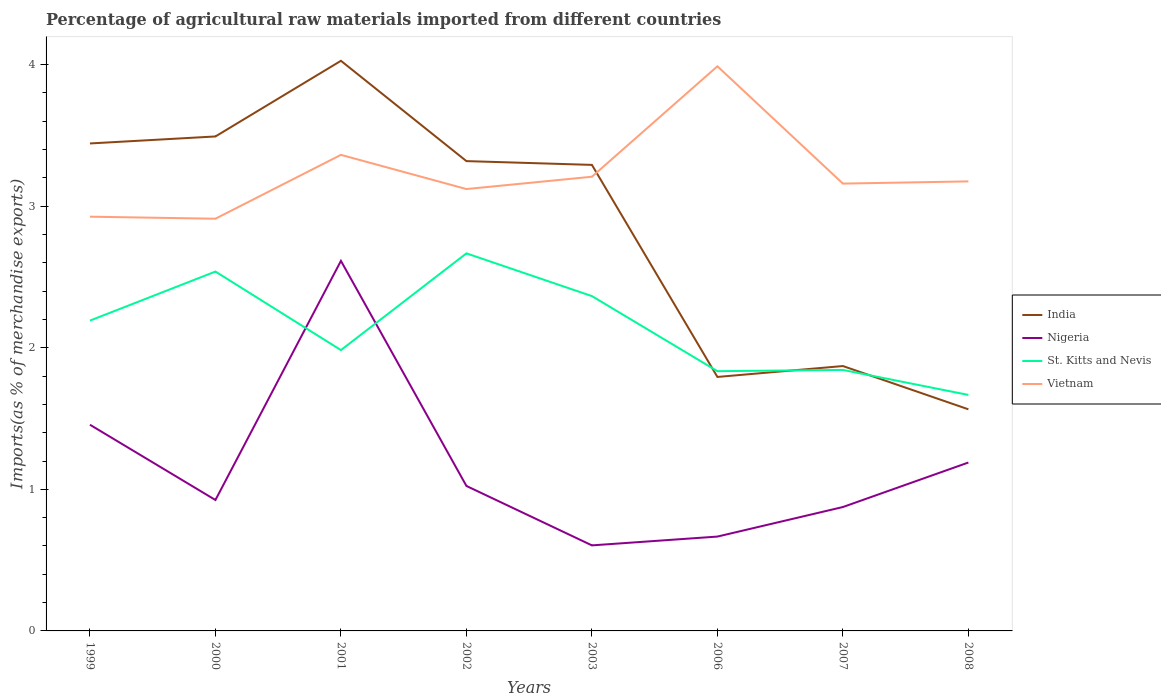How many different coloured lines are there?
Give a very brief answer. 4. Across all years, what is the maximum percentage of imports to different countries in Vietnam?
Offer a very short reply. 2.91. What is the total percentage of imports to different countries in St. Kitts and Nevis in the graph?
Give a very brief answer. -0.35. What is the difference between the highest and the second highest percentage of imports to different countries in Vietnam?
Your response must be concise. 1.08. What is the difference between the highest and the lowest percentage of imports to different countries in Nigeria?
Your response must be concise. 3. Is the percentage of imports to different countries in Vietnam strictly greater than the percentage of imports to different countries in Nigeria over the years?
Your answer should be very brief. No. How many years are there in the graph?
Offer a very short reply. 8. What is the difference between two consecutive major ticks on the Y-axis?
Ensure brevity in your answer.  1. Are the values on the major ticks of Y-axis written in scientific E-notation?
Provide a succinct answer. No. Does the graph contain any zero values?
Ensure brevity in your answer.  No. Does the graph contain grids?
Provide a short and direct response. No. How are the legend labels stacked?
Provide a short and direct response. Vertical. What is the title of the graph?
Offer a very short reply. Percentage of agricultural raw materials imported from different countries. Does "Burkina Faso" appear as one of the legend labels in the graph?
Offer a terse response. No. What is the label or title of the Y-axis?
Your answer should be very brief. Imports(as % of merchandise exports). What is the Imports(as % of merchandise exports) in India in 1999?
Ensure brevity in your answer.  3.44. What is the Imports(as % of merchandise exports) of Nigeria in 1999?
Provide a succinct answer. 1.46. What is the Imports(as % of merchandise exports) of St. Kitts and Nevis in 1999?
Ensure brevity in your answer.  2.19. What is the Imports(as % of merchandise exports) of Vietnam in 1999?
Keep it short and to the point. 2.93. What is the Imports(as % of merchandise exports) of India in 2000?
Your answer should be very brief. 3.49. What is the Imports(as % of merchandise exports) of Nigeria in 2000?
Provide a short and direct response. 0.92. What is the Imports(as % of merchandise exports) of St. Kitts and Nevis in 2000?
Ensure brevity in your answer.  2.54. What is the Imports(as % of merchandise exports) in Vietnam in 2000?
Provide a short and direct response. 2.91. What is the Imports(as % of merchandise exports) of India in 2001?
Your answer should be very brief. 4.03. What is the Imports(as % of merchandise exports) in Nigeria in 2001?
Provide a short and direct response. 2.61. What is the Imports(as % of merchandise exports) of St. Kitts and Nevis in 2001?
Offer a terse response. 1.98. What is the Imports(as % of merchandise exports) of Vietnam in 2001?
Give a very brief answer. 3.36. What is the Imports(as % of merchandise exports) in India in 2002?
Make the answer very short. 3.32. What is the Imports(as % of merchandise exports) in Nigeria in 2002?
Your answer should be compact. 1.02. What is the Imports(as % of merchandise exports) of St. Kitts and Nevis in 2002?
Give a very brief answer. 2.67. What is the Imports(as % of merchandise exports) in Vietnam in 2002?
Keep it short and to the point. 3.12. What is the Imports(as % of merchandise exports) of India in 2003?
Your answer should be very brief. 3.29. What is the Imports(as % of merchandise exports) of Nigeria in 2003?
Keep it short and to the point. 0.6. What is the Imports(as % of merchandise exports) in St. Kitts and Nevis in 2003?
Make the answer very short. 2.36. What is the Imports(as % of merchandise exports) in Vietnam in 2003?
Make the answer very short. 3.21. What is the Imports(as % of merchandise exports) of India in 2006?
Your response must be concise. 1.79. What is the Imports(as % of merchandise exports) in Nigeria in 2006?
Your response must be concise. 0.67. What is the Imports(as % of merchandise exports) in St. Kitts and Nevis in 2006?
Your answer should be compact. 1.83. What is the Imports(as % of merchandise exports) of Vietnam in 2006?
Give a very brief answer. 3.99. What is the Imports(as % of merchandise exports) of India in 2007?
Your answer should be compact. 1.87. What is the Imports(as % of merchandise exports) of Nigeria in 2007?
Keep it short and to the point. 0.87. What is the Imports(as % of merchandise exports) of St. Kitts and Nevis in 2007?
Provide a short and direct response. 1.84. What is the Imports(as % of merchandise exports) of Vietnam in 2007?
Ensure brevity in your answer.  3.16. What is the Imports(as % of merchandise exports) in India in 2008?
Offer a very short reply. 1.57. What is the Imports(as % of merchandise exports) of Nigeria in 2008?
Keep it short and to the point. 1.19. What is the Imports(as % of merchandise exports) of St. Kitts and Nevis in 2008?
Your answer should be very brief. 1.67. What is the Imports(as % of merchandise exports) in Vietnam in 2008?
Your answer should be compact. 3.17. Across all years, what is the maximum Imports(as % of merchandise exports) in India?
Give a very brief answer. 4.03. Across all years, what is the maximum Imports(as % of merchandise exports) in Nigeria?
Give a very brief answer. 2.61. Across all years, what is the maximum Imports(as % of merchandise exports) in St. Kitts and Nevis?
Make the answer very short. 2.67. Across all years, what is the maximum Imports(as % of merchandise exports) in Vietnam?
Offer a very short reply. 3.99. Across all years, what is the minimum Imports(as % of merchandise exports) in India?
Provide a short and direct response. 1.57. Across all years, what is the minimum Imports(as % of merchandise exports) in Nigeria?
Give a very brief answer. 0.6. Across all years, what is the minimum Imports(as % of merchandise exports) in St. Kitts and Nevis?
Provide a short and direct response. 1.67. Across all years, what is the minimum Imports(as % of merchandise exports) of Vietnam?
Make the answer very short. 2.91. What is the total Imports(as % of merchandise exports) in India in the graph?
Keep it short and to the point. 22.8. What is the total Imports(as % of merchandise exports) in Nigeria in the graph?
Your response must be concise. 9.35. What is the total Imports(as % of merchandise exports) in St. Kitts and Nevis in the graph?
Offer a very short reply. 17.09. What is the total Imports(as % of merchandise exports) in Vietnam in the graph?
Provide a succinct answer. 25.85. What is the difference between the Imports(as % of merchandise exports) of India in 1999 and that in 2000?
Your response must be concise. -0.05. What is the difference between the Imports(as % of merchandise exports) of Nigeria in 1999 and that in 2000?
Your answer should be compact. 0.53. What is the difference between the Imports(as % of merchandise exports) in St. Kitts and Nevis in 1999 and that in 2000?
Your answer should be very brief. -0.35. What is the difference between the Imports(as % of merchandise exports) in Vietnam in 1999 and that in 2000?
Provide a succinct answer. 0.01. What is the difference between the Imports(as % of merchandise exports) in India in 1999 and that in 2001?
Offer a very short reply. -0.58. What is the difference between the Imports(as % of merchandise exports) in Nigeria in 1999 and that in 2001?
Give a very brief answer. -1.16. What is the difference between the Imports(as % of merchandise exports) in St. Kitts and Nevis in 1999 and that in 2001?
Your response must be concise. 0.21. What is the difference between the Imports(as % of merchandise exports) in Vietnam in 1999 and that in 2001?
Your answer should be compact. -0.44. What is the difference between the Imports(as % of merchandise exports) of India in 1999 and that in 2002?
Keep it short and to the point. 0.12. What is the difference between the Imports(as % of merchandise exports) of Nigeria in 1999 and that in 2002?
Keep it short and to the point. 0.43. What is the difference between the Imports(as % of merchandise exports) in St. Kitts and Nevis in 1999 and that in 2002?
Provide a succinct answer. -0.47. What is the difference between the Imports(as % of merchandise exports) in Vietnam in 1999 and that in 2002?
Your answer should be compact. -0.2. What is the difference between the Imports(as % of merchandise exports) of India in 1999 and that in 2003?
Provide a short and direct response. 0.15. What is the difference between the Imports(as % of merchandise exports) of Nigeria in 1999 and that in 2003?
Give a very brief answer. 0.85. What is the difference between the Imports(as % of merchandise exports) in St. Kitts and Nevis in 1999 and that in 2003?
Your answer should be very brief. -0.17. What is the difference between the Imports(as % of merchandise exports) of Vietnam in 1999 and that in 2003?
Make the answer very short. -0.28. What is the difference between the Imports(as % of merchandise exports) in India in 1999 and that in 2006?
Your response must be concise. 1.65. What is the difference between the Imports(as % of merchandise exports) of Nigeria in 1999 and that in 2006?
Provide a short and direct response. 0.79. What is the difference between the Imports(as % of merchandise exports) of St. Kitts and Nevis in 1999 and that in 2006?
Keep it short and to the point. 0.36. What is the difference between the Imports(as % of merchandise exports) of Vietnam in 1999 and that in 2006?
Keep it short and to the point. -1.06. What is the difference between the Imports(as % of merchandise exports) in India in 1999 and that in 2007?
Your response must be concise. 1.57. What is the difference between the Imports(as % of merchandise exports) of Nigeria in 1999 and that in 2007?
Your answer should be very brief. 0.58. What is the difference between the Imports(as % of merchandise exports) in St. Kitts and Nevis in 1999 and that in 2007?
Ensure brevity in your answer.  0.35. What is the difference between the Imports(as % of merchandise exports) of Vietnam in 1999 and that in 2007?
Provide a succinct answer. -0.23. What is the difference between the Imports(as % of merchandise exports) in India in 1999 and that in 2008?
Provide a succinct answer. 1.88. What is the difference between the Imports(as % of merchandise exports) of Nigeria in 1999 and that in 2008?
Your answer should be compact. 0.27. What is the difference between the Imports(as % of merchandise exports) in St. Kitts and Nevis in 1999 and that in 2008?
Provide a short and direct response. 0.52. What is the difference between the Imports(as % of merchandise exports) of Vietnam in 1999 and that in 2008?
Your answer should be very brief. -0.25. What is the difference between the Imports(as % of merchandise exports) of India in 2000 and that in 2001?
Provide a succinct answer. -0.53. What is the difference between the Imports(as % of merchandise exports) in Nigeria in 2000 and that in 2001?
Provide a short and direct response. -1.69. What is the difference between the Imports(as % of merchandise exports) of St. Kitts and Nevis in 2000 and that in 2001?
Give a very brief answer. 0.55. What is the difference between the Imports(as % of merchandise exports) in Vietnam in 2000 and that in 2001?
Provide a short and direct response. -0.45. What is the difference between the Imports(as % of merchandise exports) in India in 2000 and that in 2002?
Provide a succinct answer. 0.17. What is the difference between the Imports(as % of merchandise exports) of Nigeria in 2000 and that in 2002?
Your response must be concise. -0.1. What is the difference between the Imports(as % of merchandise exports) in St. Kitts and Nevis in 2000 and that in 2002?
Your answer should be compact. -0.13. What is the difference between the Imports(as % of merchandise exports) of Vietnam in 2000 and that in 2002?
Offer a terse response. -0.21. What is the difference between the Imports(as % of merchandise exports) of India in 2000 and that in 2003?
Offer a terse response. 0.2. What is the difference between the Imports(as % of merchandise exports) in Nigeria in 2000 and that in 2003?
Offer a very short reply. 0.32. What is the difference between the Imports(as % of merchandise exports) in St. Kitts and Nevis in 2000 and that in 2003?
Offer a terse response. 0.17. What is the difference between the Imports(as % of merchandise exports) of Vietnam in 2000 and that in 2003?
Offer a very short reply. -0.3. What is the difference between the Imports(as % of merchandise exports) in India in 2000 and that in 2006?
Make the answer very short. 1.7. What is the difference between the Imports(as % of merchandise exports) of Nigeria in 2000 and that in 2006?
Provide a succinct answer. 0.26. What is the difference between the Imports(as % of merchandise exports) of St. Kitts and Nevis in 2000 and that in 2006?
Offer a very short reply. 0.7. What is the difference between the Imports(as % of merchandise exports) in Vietnam in 2000 and that in 2006?
Keep it short and to the point. -1.08. What is the difference between the Imports(as % of merchandise exports) in India in 2000 and that in 2007?
Your answer should be very brief. 1.62. What is the difference between the Imports(as % of merchandise exports) in Nigeria in 2000 and that in 2007?
Provide a succinct answer. 0.05. What is the difference between the Imports(as % of merchandise exports) in St. Kitts and Nevis in 2000 and that in 2007?
Provide a succinct answer. 0.69. What is the difference between the Imports(as % of merchandise exports) of Vietnam in 2000 and that in 2007?
Provide a succinct answer. -0.25. What is the difference between the Imports(as % of merchandise exports) in India in 2000 and that in 2008?
Keep it short and to the point. 1.93. What is the difference between the Imports(as % of merchandise exports) of Nigeria in 2000 and that in 2008?
Offer a terse response. -0.26. What is the difference between the Imports(as % of merchandise exports) of St. Kitts and Nevis in 2000 and that in 2008?
Your response must be concise. 0.87. What is the difference between the Imports(as % of merchandise exports) of Vietnam in 2000 and that in 2008?
Keep it short and to the point. -0.26. What is the difference between the Imports(as % of merchandise exports) in India in 2001 and that in 2002?
Give a very brief answer. 0.71. What is the difference between the Imports(as % of merchandise exports) of Nigeria in 2001 and that in 2002?
Give a very brief answer. 1.59. What is the difference between the Imports(as % of merchandise exports) in St. Kitts and Nevis in 2001 and that in 2002?
Keep it short and to the point. -0.68. What is the difference between the Imports(as % of merchandise exports) of Vietnam in 2001 and that in 2002?
Your response must be concise. 0.24. What is the difference between the Imports(as % of merchandise exports) of India in 2001 and that in 2003?
Your response must be concise. 0.73. What is the difference between the Imports(as % of merchandise exports) in Nigeria in 2001 and that in 2003?
Ensure brevity in your answer.  2.01. What is the difference between the Imports(as % of merchandise exports) of St. Kitts and Nevis in 2001 and that in 2003?
Keep it short and to the point. -0.38. What is the difference between the Imports(as % of merchandise exports) in Vietnam in 2001 and that in 2003?
Your answer should be compact. 0.15. What is the difference between the Imports(as % of merchandise exports) in India in 2001 and that in 2006?
Give a very brief answer. 2.23. What is the difference between the Imports(as % of merchandise exports) of Nigeria in 2001 and that in 2006?
Provide a short and direct response. 1.95. What is the difference between the Imports(as % of merchandise exports) of St. Kitts and Nevis in 2001 and that in 2006?
Offer a very short reply. 0.15. What is the difference between the Imports(as % of merchandise exports) in Vietnam in 2001 and that in 2006?
Your answer should be compact. -0.63. What is the difference between the Imports(as % of merchandise exports) in India in 2001 and that in 2007?
Your answer should be very brief. 2.16. What is the difference between the Imports(as % of merchandise exports) of Nigeria in 2001 and that in 2007?
Give a very brief answer. 1.74. What is the difference between the Imports(as % of merchandise exports) of St. Kitts and Nevis in 2001 and that in 2007?
Keep it short and to the point. 0.14. What is the difference between the Imports(as % of merchandise exports) of Vietnam in 2001 and that in 2007?
Make the answer very short. 0.2. What is the difference between the Imports(as % of merchandise exports) of India in 2001 and that in 2008?
Offer a very short reply. 2.46. What is the difference between the Imports(as % of merchandise exports) in Nigeria in 2001 and that in 2008?
Make the answer very short. 1.42. What is the difference between the Imports(as % of merchandise exports) in St. Kitts and Nevis in 2001 and that in 2008?
Make the answer very short. 0.32. What is the difference between the Imports(as % of merchandise exports) in Vietnam in 2001 and that in 2008?
Make the answer very short. 0.19. What is the difference between the Imports(as % of merchandise exports) in India in 2002 and that in 2003?
Keep it short and to the point. 0.03. What is the difference between the Imports(as % of merchandise exports) in Nigeria in 2002 and that in 2003?
Give a very brief answer. 0.42. What is the difference between the Imports(as % of merchandise exports) of St. Kitts and Nevis in 2002 and that in 2003?
Make the answer very short. 0.3. What is the difference between the Imports(as % of merchandise exports) in Vietnam in 2002 and that in 2003?
Give a very brief answer. -0.09. What is the difference between the Imports(as % of merchandise exports) in India in 2002 and that in 2006?
Give a very brief answer. 1.52. What is the difference between the Imports(as % of merchandise exports) in Nigeria in 2002 and that in 2006?
Keep it short and to the point. 0.36. What is the difference between the Imports(as % of merchandise exports) in St. Kitts and Nevis in 2002 and that in 2006?
Offer a terse response. 0.83. What is the difference between the Imports(as % of merchandise exports) in Vietnam in 2002 and that in 2006?
Keep it short and to the point. -0.87. What is the difference between the Imports(as % of merchandise exports) in India in 2002 and that in 2007?
Your response must be concise. 1.45. What is the difference between the Imports(as % of merchandise exports) in Nigeria in 2002 and that in 2007?
Your answer should be very brief. 0.15. What is the difference between the Imports(as % of merchandise exports) in St. Kitts and Nevis in 2002 and that in 2007?
Provide a short and direct response. 0.82. What is the difference between the Imports(as % of merchandise exports) in Vietnam in 2002 and that in 2007?
Your answer should be compact. -0.04. What is the difference between the Imports(as % of merchandise exports) of India in 2002 and that in 2008?
Keep it short and to the point. 1.75. What is the difference between the Imports(as % of merchandise exports) in Nigeria in 2002 and that in 2008?
Make the answer very short. -0.17. What is the difference between the Imports(as % of merchandise exports) of Vietnam in 2002 and that in 2008?
Give a very brief answer. -0.05. What is the difference between the Imports(as % of merchandise exports) in India in 2003 and that in 2006?
Provide a short and direct response. 1.5. What is the difference between the Imports(as % of merchandise exports) in Nigeria in 2003 and that in 2006?
Offer a very short reply. -0.06. What is the difference between the Imports(as % of merchandise exports) in St. Kitts and Nevis in 2003 and that in 2006?
Your answer should be very brief. 0.53. What is the difference between the Imports(as % of merchandise exports) in Vietnam in 2003 and that in 2006?
Offer a terse response. -0.78. What is the difference between the Imports(as % of merchandise exports) of India in 2003 and that in 2007?
Offer a terse response. 1.42. What is the difference between the Imports(as % of merchandise exports) in Nigeria in 2003 and that in 2007?
Give a very brief answer. -0.27. What is the difference between the Imports(as % of merchandise exports) in St. Kitts and Nevis in 2003 and that in 2007?
Provide a short and direct response. 0.52. What is the difference between the Imports(as % of merchandise exports) of Vietnam in 2003 and that in 2007?
Ensure brevity in your answer.  0.05. What is the difference between the Imports(as % of merchandise exports) in India in 2003 and that in 2008?
Provide a short and direct response. 1.73. What is the difference between the Imports(as % of merchandise exports) in Nigeria in 2003 and that in 2008?
Provide a short and direct response. -0.59. What is the difference between the Imports(as % of merchandise exports) of St. Kitts and Nevis in 2003 and that in 2008?
Keep it short and to the point. 0.7. What is the difference between the Imports(as % of merchandise exports) in Vietnam in 2003 and that in 2008?
Make the answer very short. 0.03. What is the difference between the Imports(as % of merchandise exports) in India in 2006 and that in 2007?
Provide a short and direct response. -0.08. What is the difference between the Imports(as % of merchandise exports) of Nigeria in 2006 and that in 2007?
Make the answer very short. -0.21. What is the difference between the Imports(as % of merchandise exports) of St. Kitts and Nevis in 2006 and that in 2007?
Offer a terse response. -0.01. What is the difference between the Imports(as % of merchandise exports) in Vietnam in 2006 and that in 2007?
Offer a terse response. 0.83. What is the difference between the Imports(as % of merchandise exports) in India in 2006 and that in 2008?
Make the answer very short. 0.23. What is the difference between the Imports(as % of merchandise exports) in Nigeria in 2006 and that in 2008?
Your answer should be compact. -0.52. What is the difference between the Imports(as % of merchandise exports) in St. Kitts and Nevis in 2006 and that in 2008?
Your response must be concise. 0.17. What is the difference between the Imports(as % of merchandise exports) in Vietnam in 2006 and that in 2008?
Make the answer very short. 0.81. What is the difference between the Imports(as % of merchandise exports) in India in 2007 and that in 2008?
Provide a succinct answer. 0.31. What is the difference between the Imports(as % of merchandise exports) of Nigeria in 2007 and that in 2008?
Give a very brief answer. -0.31. What is the difference between the Imports(as % of merchandise exports) in St. Kitts and Nevis in 2007 and that in 2008?
Your response must be concise. 0.18. What is the difference between the Imports(as % of merchandise exports) of Vietnam in 2007 and that in 2008?
Make the answer very short. -0.02. What is the difference between the Imports(as % of merchandise exports) of India in 1999 and the Imports(as % of merchandise exports) of Nigeria in 2000?
Offer a very short reply. 2.52. What is the difference between the Imports(as % of merchandise exports) of India in 1999 and the Imports(as % of merchandise exports) of St. Kitts and Nevis in 2000?
Your answer should be compact. 0.9. What is the difference between the Imports(as % of merchandise exports) of India in 1999 and the Imports(as % of merchandise exports) of Vietnam in 2000?
Your response must be concise. 0.53. What is the difference between the Imports(as % of merchandise exports) of Nigeria in 1999 and the Imports(as % of merchandise exports) of St. Kitts and Nevis in 2000?
Ensure brevity in your answer.  -1.08. What is the difference between the Imports(as % of merchandise exports) in Nigeria in 1999 and the Imports(as % of merchandise exports) in Vietnam in 2000?
Give a very brief answer. -1.45. What is the difference between the Imports(as % of merchandise exports) of St. Kitts and Nevis in 1999 and the Imports(as % of merchandise exports) of Vietnam in 2000?
Provide a short and direct response. -0.72. What is the difference between the Imports(as % of merchandise exports) of India in 1999 and the Imports(as % of merchandise exports) of Nigeria in 2001?
Offer a terse response. 0.83. What is the difference between the Imports(as % of merchandise exports) in India in 1999 and the Imports(as % of merchandise exports) in St. Kitts and Nevis in 2001?
Your answer should be very brief. 1.46. What is the difference between the Imports(as % of merchandise exports) in India in 1999 and the Imports(as % of merchandise exports) in Vietnam in 2001?
Ensure brevity in your answer.  0.08. What is the difference between the Imports(as % of merchandise exports) in Nigeria in 1999 and the Imports(as % of merchandise exports) in St. Kitts and Nevis in 2001?
Keep it short and to the point. -0.53. What is the difference between the Imports(as % of merchandise exports) in Nigeria in 1999 and the Imports(as % of merchandise exports) in Vietnam in 2001?
Your response must be concise. -1.91. What is the difference between the Imports(as % of merchandise exports) in St. Kitts and Nevis in 1999 and the Imports(as % of merchandise exports) in Vietnam in 2001?
Offer a terse response. -1.17. What is the difference between the Imports(as % of merchandise exports) of India in 1999 and the Imports(as % of merchandise exports) of Nigeria in 2002?
Offer a very short reply. 2.42. What is the difference between the Imports(as % of merchandise exports) in India in 1999 and the Imports(as % of merchandise exports) in St. Kitts and Nevis in 2002?
Keep it short and to the point. 0.78. What is the difference between the Imports(as % of merchandise exports) in India in 1999 and the Imports(as % of merchandise exports) in Vietnam in 2002?
Your response must be concise. 0.32. What is the difference between the Imports(as % of merchandise exports) in Nigeria in 1999 and the Imports(as % of merchandise exports) in St. Kitts and Nevis in 2002?
Your answer should be compact. -1.21. What is the difference between the Imports(as % of merchandise exports) in Nigeria in 1999 and the Imports(as % of merchandise exports) in Vietnam in 2002?
Keep it short and to the point. -1.66. What is the difference between the Imports(as % of merchandise exports) in St. Kitts and Nevis in 1999 and the Imports(as % of merchandise exports) in Vietnam in 2002?
Your response must be concise. -0.93. What is the difference between the Imports(as % of merchandise exports) in India in 1999 and the Imports(as % of merchandise exports) in Nigeria in 2003?
Give a very brief answer. 2.84. What is the difference between the Imports(as % of merchandise exports) of India in 1999 and the Imports(as % of merchandise exports) of St. Kitts and Nevis in 2003?
Your answer should be very brief. 1.08. What is the difference between the Imports(as % of merchandise exports) in India in 1999 and the Imports(as % of merchandise exports) in Vietnam in 2003?
Keep it short and to the point. 0.24. What is the difference between the Imports(as % of merchandise exports) in Nigeria in 1999 and the Imports(as % of merchandise exports) in St. Kitts and Nevis in 2003?
Give a very brief answer. -0.91. What is the difference between the Imports(as % of merchandise exports) of Nigeria in 1999 and the Imports(as % of merchandise exports) of Vietnam in 2003?
Offer a terse response. -1.75. What is the difference between the Imports(as % of merchandise exports) in St. Kitts and Nevis in 1999 and the Imports(as % of merchandise exports) in Vietnam in 2003?
Offer a terse response. -1.02. What is the difference between the Imports(as % of merchandise exports) in India in 1999 and the Imports(as % of merchandise exports) in Nigeria in 2006?
Your answer should be very brief. 2.78. What is the difference between the Imports(as % of merchandise exports) of India in 1999 and the Imports(as % of merchandise exports) of St. Kitts and Nevis in 2006?
Give a very brief answer. 1.61. What is the difference between the Imports(as % of merchandise exports) of India in 1999 and the Imports(as % of merchandise exports) of Vietnam in 2006?
Your response must be concise. -0.55. What is the difference between the Imports(as % of merchandise exports) in Nigeria in 1999 and the Imports(as % of merchandise exports) in St. Kitts and Nevis in 2006?
Provide a short and direct response. -0.38. What is the difference between the Imports(as % of merchandise exports) in Nigeria in 1999 and the Imports(as % of merchandise exports) in Vietnam in 2006?
Provide a short and direct response. -2.53. What is the difference between the Imports(as % of merchandise exports) of St. Kitts and Nevis in 1999 and the Imports(as % of merchandise exports) of Vietnam in 2006?
Provide a succinct answer. -1.8. What is the difference between the Imports(as % of merchandise exports) in India in 1999 and the Imports(as % of merchandise exports) in Nigeria in 2007?
Offer a terse response. 2.57. What is the difference between the Imports(as % of merchandise exports) of India in 1999 and the Imports(as % of merchandise exports) of St. Kitts and Nevis in 2007?
Ensure brevity in your answer.  1.6. What is the difference between the Imports(as % of merchandise exports) in India in 1999 and the Imports(as % of merchandise exports) in Vietnam in 2007?
Keep it short and to the point. 0.28. What is the difference between the Imports(as % of merchandise exports) in Nigeria in 1999 and the Imports(as % of merchandise exports) in St. Kitts and Nevis in 2007?
Provide a succinct answer. -0.39. What is the difference between the Imports(as % of merchandise exports) of Nigeria in 1999 and the Imports(as % of merchandise exports) of Vietnam in 2007?
Keep it short and to the point. -1.7. What is the difference between the Imports(as % of merchandise exports) in St. Kitts and Nevis in 1999 and the Imports(as % of merchandise exports) in Vietnam in 2007?
Your response must be concise. -0.97. What is the difference between the Imports(as % of merchandise exports) in India in 1999 and the Imports(as % of merchandise exports) in Nigeria in 2008?
Make the answer very short. 2.25. What is the difference between the Imports(as % of merchandise exports) of India in 1999 and the Imports(as % of merchandise exports) of St. Kitts and Nevis in 2008?
Give a very brief answer. 1.78. What is the difference between the Imports(as % of merchandise exports) of India in 1999 and the Imports(as % of merchandise exports) of Vietnam in 2008?
Your answer should be compact. 0.27. What is the difference between the Imports(as % of merchandise exports) in Nigeria in 1999 and the Imports(as % of merchandise exports) in St. Kitts and Nevis in 2008?
Your response must be concise. -0.21. What is the difference between the Imports(as % of merchandise exports) of Nigeria in 1999 and the Imports(as % of merchandise exports) of Vietnam in 2008?
Ensure brevity in your answer.  -1.72. What is the difference between the Imports(as % of merchandise exports) in St. Kitts and Nevis in 1999 and the Imports(as % of merchandise exports) in Vietnam in 2008?
Offer a very short reply. -0.98. What is the difference between the Imports(as % of merchandise exports) of India in 2000 and the Imports(as % of merchandise exports) of Nigeria in 2001?
Offer a very short reply. 0.88. What is the difference between the Imports(as % of merchandise exports) of India in 2000 and the Imports(as % of merchandise exports) of St. Kitts and Nevis in 2001?
Give a very brief answer. 1.51. What is the difference between the Imports(as % of merchandise exports) of India in 2000 and the Imports(as % of merchandise exports) of Vietnam in 2001?
Give a very brief answer. 0.13. What is the difference between the Imports(as % of merchandise exports) of Nigeria in 2000 and the Imports(as % of merchandise exports) of St. Kitts and Nevis in 2001?
Offer a terse response. -1.06. What is the difference between the Imports(as % of merchandise exports) of Nigeria in 2000 and the Imports(as % of merchandise exports) of Vietnam in 2001?
Provide a short and direct response. -2.44. What is the difference between the Imports(as % of merchandise exports) of St. Kitts and Nevis in 2000 and the Imports(as % of merchandise exports) of Vietnam in 2001?
Give a very brief answer. -0.82. What is the difference between the Imports(as % of merchandise exports) in India in 2000 and the Imports(as % of merchandise exports) in Nigeria in 2002?
Your response must be concise. 2.47. What is the difference between the Imports(as % of merchandise exports) in India in 2000 and the Imports(as % of merchandise exports) in St. Kitts and Nevis in 2002?
Make the answer very short. 0.83. What is the difference between the Imports(as % of merchandise exports) of India in 2000 and the Imports(as % of merchandise exports) of Vietnam in 2002?
Your answer should be very brief. 0.37. What is the difference between the Imports(as % of merchandise exports) of Nigeria in 2000 and the Imports(as % of merchandise exports) of St. Kitts and Nevis in 2002?
Your answer should be compact. -1.74. What is the difference between the Imports(as % of merchandise exports) in Nigeria in 2000 and the Imports(as % of merchandise exports) in Vietnam in 2002?
Make the answer very short. -2.2. What is the difference between the Imports(as % of merchandise exports) in St. Kitts and Nevis in 2000 and the Imports(as % of merchandise exports) in Vietnam in 2002?
Keep it short and to the point. -0.58. What is the difference between the Imports(as % of merchandise exports) of India in 2000 and the Imports(as % of merchandise exports) of Nigeria in 2003?
Your response must be concise. 2.89. What is the difference between the Imports(as % of merchandise exports) of India in 2000 and the Imports(as % of merchandise exports) of St. Kitts and Nevis in 2003?
Your answer should be compact. 1.13. What is the difference between the Imports(as % of merchandise exports) of India in 2000 and the Imports(as % of merchandise exports) of Vietnam in 2003?
Ensure brevity in your answer.  0.28. What is the difference between the Imports(as % of merchandise exports) in Nigeria in 2000 and the Imports(as % of merchandise exports) in St. Kitts and Nevis in 2003?
Provide a succinct answer. -1.44. What is the difference between the Imports(as % of merchandise exports) in Nigeria in 2000 and the Imports(as % of merchandise exports) in Vietnam in 2003?
Offer a terse response. -2.28. What is the difference between the Imports(as % of merchandise exports) in St. Kitts and Nevis in 2000 and the Imports(as % of merchandise exports) in Vietnam in 2003?
Make the answer very short. -0.67. What is the difference between the Imports(as % of merchandise exports) of India in 2000 and the Imports(as % of merchandise exports) of Nigeria in 2006?
Keep it short and to the point. 2.83. What is the difference between the Imports(as % of merchandise exports) of India in 2000 and the Imports(as % of merchandise exports) of St. Kitts and Nevis in 2006?
Ensure brevity in your answer.  1.66. What is the difference between the Imports(as % of merchandise exports) of India in 2000 and the Imports(as % of merchandise exports) of Vietnam in 2006?
Ensure brevity in your answer.  -0.5. What is the difference between the Imports(as % of merchandise exports) in Nigeria in 2000 and the Imports(as % of merchandise exports) in St. Kitts and Nevis in 2006?
Provide a succinct answer. -0.91. What is the difference between the Imports(as % of merchandise exports) in Nigeria in 2000 and the Imports(as % of merchandise exports) in Vietnam in 2006?
Your answer should be very brief. -3.06. What is the difference between the Imports(as % of merchandise exports) of St. Kitts and Nevis in 2000 and the Imports(as % of merchandise exports) of Vietnam in 2006?
Make the answer very short. -1.45. What is the difference between the Imports(as % of merchandise exports) in India in 2000 and the Imports(as % of merchandise exports) in Nigeria in 2007?
Keep it short and to the point. 2.62. What is the difference between the Imports(as % of merchandise exports) of India in 2000 and the Imports(as % of merchandise exports) of St. Kitts and Nevis in 2007?
Your answer should be compact. 1.65. What is the difference between the Imports(as % of merchandise exports) of India in 2000 and the Imports(as % of merchandise exports) of Vietnam in 2007?
Ensure brevity in your answer.  0.33. What is the difference between the Imports(as % of merchandise exports) in Nigeria in 2000 and the Imports(as % of merchandise exports) in St. Kitts and Nevis in 2007?
Provide a succinct answer. -0.92. What is the difference between the Imports(as % of merchandise exports) of Nigeria in 2000 and the Imports(as % of merchandise exports) of Vietnam in 2007?
Offer a very short reply. -2.23. What is the difference between the Imports(as % of merchandise exports) of St. Kitts and Nevis in 2000 and the Imports(as % of merchandise exports) of Vietnam in 2007?
Offer a terse response. -0.62. What is the difference between the Imports(as % of merchandise exports) in India in 2000 and the Imports(as % of merchandise exports) in Nigeria in 2008?
Keep it short and to the point. 2.3. What is the difference between the Imports(as % of merchandise exports) of India in 2000 and the Imports(as % of merchandise exports) of St. Kitts and Nevis in 2008?
Ensure brevity in your answer.  1.83. What is the difference between the Imports(as % of merchandise exports) of India in 2000 and the Imports(as % of merchandise exports) of Vietnam in 2008?
Provide a succinct answer. 0.32. What is the difference between the Imports(as % of merchandise exports) of Nigeria in 2000 and the Imports(as % of merchandise exports) of St. Kitts and Nevis in 2008?
Offer a very short reply. -0.74. What is the difference between the Imports(as % of merchandise exports) of Nigeria in 2000 and the Imports(as % of merchandise exports) of Vietnam in 2008?
Your response must be concise. -2.25. What is the difference between the Imports(as % of merchandise exports) in St. Kitts and Nevis in 2000 and the Imports(as % of merchandise exports) in Vietnam in 2008?
Give a very brief answer. -0.64. What is the difference between the Imports(as % of merchandise exports) in India in 2001 and the Imports(as % of merchandise exports) in Nigeria in 2002?
Your answer should be compact. 3. What is the difference between the Imports(as % of merchandise exports) of India in 2001 and the Imports(as % of merchandise exports) of St. Kitts and Nevis in 2002?
Ensure brevity in your answer.  1.36. What is the difference between the Imports(as % of merchandise exports) in India in 2001 and the Imports(as % of merchandise exports) in Vietnam in 2002?
Ensure brevity in your answer.  0.91. What is the difference between the Imports(as % of merchandise exports) in Nigeria in 2001 and the Imports(as % of merchandise exports) in St. Kitts and Nevis in 2002?
Ensure brevity in your answer.  -0.05. What is the difference between the Imports(as % of merchandise exports) of Nigeria in 2001 and the Imports(as % of merchandise exports) of Vietnam in 2002?
Ensure brevity in your answer.  -0.51. What is the difference between the Imports(as % of merchandise exports) in St. Kitts and Nevis in 2001 and the Imports(as % of merchandise exports) in Vietnam in 2002?
Your answer should be very brief. -1.14. What is the difference between the Imports(as % of merchandise exports) in India in 2001 and the Imports(as % of merchandise exports) in Nigeria in 2003?
Your answer should be compact. 3.42. What is the difference between the Imports(as % of merchandise exports) of India in 2001 and the Imports(as % of merchandise exports) of St. Kitts and Nevis in 2003?
Offer a very short reply. 1.66. What is the difference between the Imports(as % of merchandise exports) of India in 2001 and the Imports(as % of merchandise exports) of Vietnam in 2003?
Give a very brief answer. 0.82. What is the difference between the Imports(as % of merchandise exports) in Nigeria in 2001 and the Imports(as % of merchandise exports) in St. Kitts and Nevis in 2003?
Offer a very short reply. 0.25. What is the difference between the Imports(as % of merchandise exports) of Nigeria in 2001 and the Imports(as % of merchandise exports) of Vietnam in 2003?
Your answer should be compact. -0.59. What is the difference between the Imports(as % of merchandise exports) in St. Kitts and Nevis in 2001 and the Imports(as % of merchandise exports) in Vietnam in 2003?
Ensure brevity in your answer.  -1.22. What is the difference between the Imports(as % of merchandise exports) of India in 2001 and the Imports(as % of merchandise exports) of Nigeria in 2006?
Make the answer very short. 3.36. What is the difference between the Imports(as % of merchandise exports) in India in 2001 and the Imports(as % of merchandise exports) in St. Kitts and Nevis in 2006?
Offer a very short reply. 2.19. What is the difference between the Imports(as % of merchandise exports) of India in 2001 and the Imports(as % of merchandise exports) of Vietnam in 2006?
Make the answer very short. 0.04. What is the difference between the Imports(as % of merchandise exports) in Nigeria in 2001 and the Imports(as % of merchandise exports) in St. Kitts and Nevis in 2006?
Ensure brevity in your answer.  0.78. What is the difference between the Imports(as % of merchandise exports) of Nigeria in 2001 and the Imports(as % of merchandise exports) of Vietnam in 2006?
Offer a terse response. -1.37. What is the difference between the Imports(as % of merchandise exports) of St. Kitts and Nevis in 2001 and the Imports(as % of merchandise exports) of Vietnam in 2006?
Your response must be concise. -2. What is the difference between the Imports(as % of merchandise exports) of India in 2001 and the Imports(as % of merchandise exports) of Nigeria in 2007?
Offer a very short reply. 3.15. What is the difference between the Imports(as % of merchandise exports) of India in 2001 and the Imports(as % of merchandise exports) of St. Kitts and Nevis in 2007?
Offer a terse response. 2.18. What is the difference between the Imports(as % of merchandise exports) of India in 2001 and the Imports(as % of merchandise exports) of Vietnam in 2007?
Keep it short and to the point. 0.87. What is the difference between the Imports(as % of merchandise exports) of Nigeria in 2001 and the Imports(as % of merchandise exports) of St. Kitts and Nevis in 2007?
Provide a succinct answer. 0.77. What is the difference between the Imports(as % of merchandise exports) in Nigeria in 2001 and the Imports(as % of merchandise exports) in Vietnam in 2007?
Your answer should be very brief. -0.55. What is the difference between the Imports(as % of merchandise exports) of St. Kitts and Nevis in 2001 and the Imports(as % of merchandise exports) of Vietnam in 2007?
Give a very brief answer. -1.18. What is the difference between the Imports(as % of merchandise exports) in India in 2001 and the Imports(as % of merchandise exports) in Nigeria in 2008?
Make the answer very short. 2.84. What is the difference between the Imports(as % of merchandise exports) in India in 2001 and the Imports(as % of merchandise exports) in St. Kitts and Nevis in 2008?
Ensure brevity in your answer.  2.36. What is the difference between the Imports(as % of merchandise exports) in India in 2001 and the Imports(as % of merchandise exports) in Vietnam in 2008?
Give a very brief answer. 0.85. What is the difference between the Imports(as % of merchandise exports) in Nigeria in 2001 and the Imports(as % of merchandise exports) in St. Kitts and Nevis in 2008?
Ensure brevity in your answer.  0.95. What is the difference between the Imports(as % of merchandise exports) of Nigeria in 2001 and the Imports(as % of merchandise exports) of Vietnam in 2008?
Your answer should be compact. -0.56. What is the difference between the Imports(as % of merchandise exports) of St. Kitts and Nevis in 2001 and the Imports(as % of merchandise exports) of Vietnam in 2008?
Provide a short and direct response. -1.19. What is the difference between the Imports(as % of merchandise exports) in India in 2002 and the Imports(as % of merchandise exports) in Nigeria in 2003?
Keep it short and to the point. 2.71. What is the difference between the Imports(as % of merchandise exports) of India in 2002 and the Imports(as % of merchandise exports) of St. Kitts and Nevis in 2003?
Offer a very short reply. 0.95. What is the difference between the Imports(as % of merchandise exports) in India in 2002 and the Imports(as % of merchandise exports) in Vietnam in 2003?
Keep it short and to the point. 0.11. What is the difference between the Imports(as % of merchandise exports) in Nigeria in 2002 and the Imports(as % of merchandise exports) in St. Kitts and Nevis in 2003?
Your answer should be compact. -1.34. What is the difference between the Imports(as % of merchandise exports) of Nigeria in 2002 and the Imports(as % of merchandise exports) of Vietnam in 2003?
Offer a very short reply. -2.18. What is the difference between the Imports(as % of merchandise exports) in St. Kitts and Nevis in 2002 and the Imports(as % of merchandise exports) in Vietnam in 2003?
Ensure brevity in your answer.  -0.54. What is the difference between the Imports(as % of merchandise exports) in India in 2002 and the Imports(as % of merchandise exports) in Nigeria in 2006?
Ensure brevity in your answer.  2.65. What is the difference between the Imports(as % of merchandise exports) of India in 2002 and the Imports(as % of merchandise exports) of St. Kitts and Nevis in 2006?
Offer a very short reply. 1.48. What is the difference between the Imports(as % of merchandise exports) in India in 2002 and the Imports(as % of merchandise exports) in Vietnam in 2006?
Your answer should be very brief. -0.67. What is the difference between the Imports(as % of merchandise exports) of Nigeria in 2002 and the Imports(as % of merchandise exports) of St. Kitts and Nevis in 2006?
Give a very brief answer. -0.81. What is the difference between the Imports(as % of merchandise exports) of Nigeria in 2002 and the Imports(as % of merchandise exports) of Vietnam in 2006?
Your response must be concise. -2.96. What is the difference between the Imports(as % of merchandise exports) in St. Kitts and Nevis in 2002 and the Imports(as % of merchandise exports) in Vietnam in 2006?
Your response must be concise. -1.32. What is the difference between the Imports(as % of merchandise exports) in India in 2002 and the Imports(as % of merchandise exports) in Nigeria in 2007?
Offer a terse response. 2.44. What is the difference between the Imports(as % of merchandise exports) of India in 2002 and the Imports(as % of merchandise exports) of St. Kitts and Nevis in 2007?
Offer a very short reply. 1.47. What is the difference between the Imports(as % of merchandise exports) of India in 2002 and the Imports(as % of merchandise exports) of Vietnam in 2007?
Your response must be concise. 0.16. What is the difference between the Imports(as % of merchandise exports) of Nigeria in 2002 and the Imports(as % of merchandise exports) of St. Kitts and Nevis in 2007?
Offer a terse response. -0.82. What is the difference between the Imports(as % of merchandise exports) in Nigeria in 2002 and the Imports(as % of merchandise exports) in Vietnam in 2007?
Your answer should be very brief. -2.14. What is the difference between the Imports(as % of merchandise exports) of St. Kitts and Nevis in 2002 and the Imports(as % of merchandise exports) of Vietnam in 2007?
Provide a short and direct response. -0.49. What is the difference between the Imports(as % of merchandise exports) in India in 2002 and the Imports(as % of merchandise exports) in Nigeria in 2008?
Make the answer very short. 2.13. What is the difference between the Imports(as % of merchandise exports) in India in 2002 and the Imports(as % of merchandise exports) in St. Kitts and Nevis in 2008?
Ensure brevity in your answer.  1.65. What is the difference between the Imports(as % of merchandise exports) in India in 2002 and the Imports(as % of merchandise exports) in Vietnam in 2008?
Your answer should be very brief. 0.14. What is the difference between the Imports(as % of merchandise exports) of Nigeria in 2002 and the Imports(as % of merchandise exports) of St. Kitts and Nevis in 2008?
Make the answer very short. -0.64. What is the difference between the Imports(as % of merchandise exports) of Nigeria in 2002 and the Imports(as % of merchandise exports) of Vietnam in 2008?
Provide a short and direct response. -2.15. What is the difference between the Imports(as % of merchandise exports) of St. Kitts and Nevis in 2002 and the Imports(as % of merchandise exports) of Vietnam in 2008?
Ensure brevity in your answer.  -0.51. What is the difference between the Imports(as % of merchandise exports) of India in 2003 and the Imports(as % of merchandise exports) of Nigeria in 2006?
Your response must be concise. 2.62. What is the difference between the Imports(as % of merchandise exports) in India in 2003 and the Imports(as % of merchandise exports) in St. Kitts and Nevis in 2006?
Offer a very short reply. 1.46. What is the difference between the Imports(as % of merchandise exports) of India in 2003 and the Imports(as % of merchandise exports) of Vietnam in 2006?
Provide a succinct answer. -0.7. What is the difference between the Imports(as % of merchandise exports) in Nigeria in 2003 and the Imports(as % of merchandise exports) in St. Kitts and Nevis in 2006?
Your answer should be very brief. -1.23. What is the difference between the Imports(as % of merchandise exports) of Nigeria in 2003 and the Imports(as % of merchandise exports) of Vietnam in 2006?
Keep it short and to the point. -3.38. What is the difference between the Imports(as % of merchandise exports) of St. Kitts and Nevis in 2003 and the Imports(as % of merchandise exports) of Vietnam in 2006?
Make the answer very short. -1.62. What is the difference between the Imports(as % of merchandise exports) of India in 2003 and the Imports(as % of merchandise exports) of Nigeria in 2007?
Your answer should be very brief. 2.42. What is the difference between the Imports(as % of merchandise exports) of India in 2003 and the Imports(as % of merchandise exports) of St. Kitts and Nevis in 2007?
Ensure brevity in your answer.  1.45. What is the difference between the Imports(as % of merchandise exports) in India in 2003 and the Imports(as % of merchandise exports) in Vietnam in 2007?
Ensure brevity in your answer.  0.13. What is the difference between the Imports(as % of merchandise exports) of Nigeria in 2003 and the Imports(as % of merchandise exports) of St. Kitts and Nevis in 2007?
Provide a succinct answer. -1.24. What is the difference between the Imports(as % of merchandise exports) in Nigeria in 2003 and the Imports(as % of merchandise exports) in Vietnam in 2007?
Make the answer very short. -2.55. What is the difference between the Imports(as % of merchandise exports) of St. Kitts and Nevis in 2003 and the Imports(as % of merchandise exports) of Vietnam in 2007?
Offer a terse response. -0.79. What is the difference between the Imports(as % of merchandise exports) in India in 2003 and the Imports(as % of merchandise exports) in Nigeria in 2008?
Offer a terse response. 2.1. What is the difference between the Imports(as % of merchandise exports) in India in 2003 and the Imports(as % of merchandise exports) in St. Kitts and Nevis in 2008?
Your answer should be compact. 1.62. What is the difference between the Imports(as % of merchandise exports) of India in 2003 and the Imports(as % of merchandise exports) of Vietnam in 2008?
Offer a very short reply. 0.12. What is the difference between the Imports(as % of merchandise exports) in Nigeria in 2003 and the Imports(as % of merchandise exports) in St. Kitts and Nevis in 2008?
Offer a very short reply. -1.06. What is the difference between the Imports(as % of merchandise exports) of Nigeria in 2003 and the Imports(as % of merchandise exports) of Vietnam in 2008?
Ensure brevity in your answer.  -2.57. What is the difference between the Imports(as % of merchandise exports) of St. Kitts and Nevis in 2003 and the Imports(as % of merchandise exports) of Vietnam in 2008?
Offer a terse response. -0.81. What is the difference between the Imports(as % of merchandise exports) of India in 2006 and the Imports(as % of merchandise exports) of Nigeria in 2007?
Make the answer very short. 0.92. What is the difference between the Imports(as % of merchandise exports) in India in 2006 and the Imports(as % of merchandise exports) in St. Kitts and Nevis in 2007?
Provide a short and direct response. -0.05. What is the difference between the Imports(as % of merchandise exports) in India in 2006 and the Imports(as % of merchandise exports) in Vietnam in 2007?
Ensure brevity in your answer.  -1.37. What is the difference between the Imports(as % of merchandise exports) of Nigeria in 2006 and the Imports(as % of merchandise exports) of St. Kitts and Nevis in 2007?
Offer a terse response. -1.18. What is the difference between the Imports(as % of merchandise exports) of Nigeria in 2006 and the Imports(as % of merchandise exports) of Vietnam in 2007?
Offer a terse response. -2.49. What is the difference between the Imports(as % of merchandise exports) of St. Kitts and Nevis in 2006 and the Imports(as % of merchandise exports) of Vietnam in 2007?
Offer a terse response. -1.32. What is the difference between the Imports(as % of merchandise exports) of India in 2006 and the Imports(as % of merchandise exports) of Nigeria in 2008?
Offer a terse response. 0.6. What is the difference between the Imports(as % of merchandise exports) of India in 2006 and the Imports(as % of merchandise exports) of St. Kitts and Nevis in 2008?
Ensure brevity in your answer.  0.13. What is the difference between the Imports(as % of merchandise exports) of India in 2006 and the Imports(as % of merchandise exports) of Vietnam in 2008?
Your answer should be compact. -1.38. What is the difference between the Imports(as % of merchandise exports) in Nigeria in 2006 and the Imports(as % of merchandise exports) in St. Kitts and Nevis in 2008?
Provide a succinct answer. -1. What is the difference between the Imports(as % of merchandise exports) of Nigeria in 2006 and the Imports(as % of merchandise exports) of Vietnam in 2008?
Keep it short and to the point. -2.51. What is the difference between the Imports(as % of merchandise exports) of St. Kitts and Nevis in 2006 and the Imports(as % of merchandise exports) of Vietnam in 2008?
Keep it short and to the point. -1.34. What is the difference between the Imports(as % of merchandise exports) of India in 2007 and the Imports(as % of merchandise exports) of Nigeria in 2008?
Your answer should be compact. 0.68. What is the difference between the Imports(as % of merchandise exports) of India in 2007 and the Imports(as % of merchandise exports) of St. Kitts and Nevis in 2008?
Provide a succinct answer. 0.2. What is the difference between the Imports(as % of merchandise exports) in India in 2007 and the Imports(as % of merchandise exports) in Vietnam in 2008?
Offer a very short reply. -1.3. What is the difference between the Imports(as % of merchandise exports) of Nigeria in 2007 and the Imports(as % of merchandise exports) of St. Kitts and Nevis in 2008?
Your answer should be very brief. -0.79. What is the difference between the Imports(as % of merchandise exports) in Nigeria in 2007 and the Imports(as % of merchandise exports) in Vietnam in 2008?
Provide a succinct answer. -2.3. What is the difference between the Imports(as % of merchandise exports) of St. Kitts and Nevis in 2007 and the Imports(as % of merchandise exports) of Vietnam in 2008?
Your response must be concise. -1.33. What is the average Imports(as % of merchandise exports) in India per year?
Your answer should be very brief. 2.85. What is the average Imports(as % of merchandise exports) of Nigeria per year?
Provide a short and direct response. 1.17. What is the average Imports(as % of merchandise exports) in St. Kitts and Nevis per year?
Your answer should be compact. 2.14. What is the average Imports(as % of merchandise exports) of Vietnam per year?
Your answer should be very brief. 3.23. In the year 1999, what is the difference between the Imports(as % of merchandise exports) in India and Imports(as % of merchandise exports) in Nigeria?
Offer a terse response. 1.99. In the year 1999, what is the difference between the Imports(as % of merchandise exports) in India and Imports(as % of merchandise exports) in St. Kitts and Nevis?
Your answer should be very brief. 1.25. In the year 1999, what is the difference between the Imports(as % of merchandise exports) in India and Imports(as % of merchandise exports) in Vietnam?
Offer a terse response. 0.52. In the year 1999, what is the difference between the Imports(as % of merchandise exports) of Nigeria and Imports(as % of merchandise exports) of St. Kitts and Nevis?
Keep it short and to the point. -0.74. In the year 1999, what is the difference between the Imports(as % of merchandise exports) of Nigeria and Imports(as % of merchandise exports) of Vietnam?
Keep it short and to the point. -1.47. In the year 1999, what is the difference between the Imports(as % of merchandise exports) of St. Kitts and Nevis and Imports(as % of merchandise exports) of Vietnam?
Provide a short and direct response. -0.73. In the year 2000, what is the difference between the Imports(as % of merchandise exports) of India and Imports(as % of merchandise exports) of Nigeria?
Offer a very short reply. 2.57. In the year 2000, what is the difference between the Imports(as % of merchandise exports) in India and Imports(as % of merchandise exports) in St. Kitts and Nevis?
Give a very brief answer. 0.95. In the year 2000, what is the difference between the Imports(as % of merchandise exports) in India and Imports(as % of merchandise exports) in Vietnam?
Give a very brief answer. 0.58. In the year 2000, what is the difference between the Imports(as % of merchandise exports) of Nigeria and Imports(as % of merchandise exports) of St. Kitts and Nevis?
Keep it short and to the point. -1.61. In the year 2000, what is the difference between the Imports(as % of merchandise exports) in Nigeria and Imports(as % of merchandise exports) in Vietnam?
Keep it short and to the point. -1.99. In the year 2000, what is the difference between the Imports(as % of merchandise exports) of St. Kitts and Nevis and Imports(as % of merchandise exports) of Vietnam?
Offer a terse response. -0.37. In the year 2001, what is the difference between the Imports(as % of merchandise exports) in India and Imports(as % of merchandise exports) in Nigeria?
Provide a short and direct response. 1.41. In the year 2001, what is the difference between the Imports(as % of merchandise exports) in India and Imports(as % of merchandise exports) in St. Kitts and Nevis?
Your answer should be compact. 2.04. In the year 2001, what is the difference between the Imports(as % of merchandise exports) of India and Imports(as % of merchandise exports) of Vietnam?
Offer a terse response. 0.66. In the year 2001, what is the difference between the Imports(as % of merchandise exports) in Nigeria and Imports(as % of merchandise exports) in St. Kitts and Nevis?
Ensure brevity in your answer.  0.63. In the year 2001, what is the difference between the Imports(as % of merchandise exports) of Nigeria and Imports(as % of merchandise exports) of Vietnam?
Keep it short and to the point. -0.75. In the year 2001, what is the difference between the Imports(as % of merchandise exports) of St. Kitts and Nevis and Imports(as % of merchandise exports) of Vietnam?
Give a very brief answer. -1.38. In the year 2002, what is the difference between the Imports(as % of merchandise exports) in India and Imports(as % of merchandise exports) in Nigeria?
Keep it short and to the point. 2.29. In the year 2002, what is the difference between the Imports(as % of merchandise exports) in India and Imports(as % of merchandise exports) in St. Kitts and Nevis?
Offer a very short reply. 0.65. In the year 2002, what is the difference between the Imports(as % of merchandise exports) of India and Imports(as % of merchandise exports) of Vietnam?
Provide a succinct answer. 0.2. In the year 2002, what is the difference between the Imports(as % of merchandise exports) in Nigeria and Imports(as % of merchandise exports) in St. Kitts and Nevis?
Offer a terse response. -1.64. In the year 2002, what is the difference between the Imports(as % of merchandise exports) of Nigeria and Imports(as % of merchandise exports) of Vietnam?
Provide a short and direct response. -2.1. In the year 2002, what is the difference between the Imports(as % of merchandise exports) in St. Kitts and Nevis and Imports(as % of merchandise exports) in Vietnam?
Your answer should be very brief. -0.45. In the year 2003, what is the difference between the Imports(as % of merchandise exports) in India and Imports(as % of merchandise exports) in Nigeria?
Ensure brevity in your answer.  2.69. In the year 2003, what is the difference between the Imports(as % of merchandise exports) of India and Imports(as % of merchandise exports) of St. Kitts and Nevis?
Offer a very short reply. 0.93. In the year 2003, what is the difference between the Imports(as % of merchandise exports) of India and Imports(as % of merchandise exports) of Vietnam?
Your response must be concise. 0.08. In the year 2003, what is the difference between the Imports(as % of merchandise exports) in Nigeria and Imports(as % of merchandise exports) in St. Kitts and Nevis?
Give a very brief answer. -1.76. In the year 2003, what is the difference between the Imports(as % of merchandise exports) in Nigeria and Imports(as % of merchandise exports) in Vietnam?
Offer a terse response. -2.6. In the year 2003, what is the difference between the Imports(as % of merchandise exports) in St. Kitts and Nevis and Imports(as % of merchandise exports) in Vietnam?
Keep it short and to the point. -0.84. In the year 2006, what is the difference between the Imports(as % of merchandise exports) in India and Imports(as % of merchandise exports) in Nigeria?
Offer a terse response. 1.13. In the year 2006, what is the difference between the Imports(as % of merchandise exports) in India and Imports(as % of merchandise exports) in St. Kitts and Nevis?
Provide a short and direct response. -0.04. In the year 2006, what is the difference between the Imports(as % of merchandise exports) in India and Imports(as % of merchandise exports) in Vietnam?
Provide a succinct answer. -2.19. In the year 2006, what is the difference between the Imports(as % of merchandise exports) in Nigeria and Imports(as % of merchandise exports) in St. Kitts and Nevis?
Give a very brief answer. -1.17. In the year 2006, what is the difference between the Imports(as % of merchandise exports) in Nigeria and Imports(as % of merchandise exports) in Vietnam?
Offer a terse response. -3.32. In the year 2006, what is the difference between the Imports(as % of merchandise exports) in St. Kitts and Nevis and Imports(as % of merchandise exports) in Vietnam?
Offer a very short reply. -2.15. In the year 2007, what is the difference between the Imports(as % of merchandise exports) of India and Imports(as % of merchandise exports) of St. Kitts and Nevis?
Make the answer very short. 0.03. In the year 2007, what is the difference between the Imports(as % of merchandise exports) of India and Imports(as % of merchandise exports) of Vietnam?
Keep it short and to the point. -1.29. In the year 2007, what is the difference between the Imports(as % of merchandise exports) in Nigeria and Imports(as % of merchandise exports) in St. Kitts and Nevis?
Your answer should be compact. -0.97. In the year 2007, what is the difference between the Imports(as % of merchandise exports) of Nigeria and Imports(as % of merchandise exports) of Vietnam?
Give a very brief answer. -2.28. In the year 2007, what is the difference between the Imports(as % of merchandise exports) of St. Kitts and Nevis and Imports(as % of merchandise exports) of Vietnam?
Offer a very short reply. -1.32. In the year 2008, what is the difference between the Imports(as % of merchandise exports) in India and Imports(as % of merchandise exports) in Nigeria?
Ensure brevity in your answer.  0.38. In the year 2008, what is the difference between the Imports(as % of merchandise exports) in India and Imports(as % of merchandise exports) in St. Kitts and Nevis?
Your answer should be compact. -0.1. In the year 2008, what is the difference between the Imports(as % of merchandise exports) of India and Imports(as % of merchandise exports) of Vietnam?
Ensure brevity in your answer.  -1.61. In the year 2008, what is the difference between the Imports(as % of merchandise exports) in Nigeria and Imports(as % of merchandise exports) in St. Kitts and Nevis?
Your response must be concise. -0.48. In the year 2008, what is the difference between the Imports(as % of merchandise exports) in Nigeria and Imports(as % of merchandise exports) in Vietnam?
Offer a terse response. -1.99. In the year 2008, what is the difference between the Imports(as % of merchandise exports) of St. Kitts and Nevis and Imports(as % of merchandise exports) of Vietnam?
Keep it short and to the point. -1.51. What is the ratio of the Imports(as % of merchandise exports) of India in 1999 to that in 2000?
Provide a short and direct response. 0.99. What is the ratio of the Imports(as % of merchandise exports) of Nigeria in 1999 to that in 2000?
Your answer should be very brief. 1.57. What is the ratio of the Imports(as % of merchandise exports) in St. Kitts and Nevis in 1999 to that in 2000?
Your response must be concise. 0.86. What is the ratio of the Imports(as % of merchandise exports) of Vietnam in 1999 to that in 2000?
Your response must be concise. 1. What is the ratio of the Imports(as % of merchandise exports) in India in 1999 to that in 2001?
Your answer should be compact. 0.85. What is the ratio of the Imports(as % of merchandise exports) of Nigeria in 1999 to that in 2001?
Make the answer very short. 0.56. What is the ratio of the Imports(as % of merchandise exports) in St. Kitts and Nevis in 1999 to that in 2001?
Make the answer very short. 1.11. What is the ratio of the Imports(as % of merchandise exports) in Vietnam in 1999 to that in 2001?
Keep it short and to the point. 0.87. What is the ratio of the Imports(as % of merchandise exports) of India in 1999 to that in 2002?
Your answer should be very brief. 1.04. What is the ratio of the Imports(as % of merchandise exports) in Nigeria in 1999 to that in 2002?
Ensure brevity in your answer.  1.42. What is the ratio of the Imports(as % of merchandise exports) of St. Kitts and Nevis in 1999 to that in 2002?
Your answer should be compact. 0.82. What is the ratio of the Imports(as % of merchandise exports) in Vietnam in 1999 to that in 2002?
Give a very brief answer. 0.94. What is the ratio of the Imports(as % of merchandise exports) in India in 1999 to that in 2003?
Provide a short and direct response. 1.05. What is the ratio of the Imports(as % of merchandise exports) in Nigeria in 1999 to that in 2003?
Provide a short and direct response. 2.41. What is the ratio of the Imports(as % of merchandise exports) of St. Kitts and Nevis in 1999 to that in 2003?
Provide a succinct answer. 0.93. What is the ratio of the Imports(as % of merchandise exports) of Vietnam in 1999 to that in 2003?
Make the answer very short. 0.91. What is the ratio of the Imports(as % of merchandise exports) in India in 1999 to that in 2006?
Offer a very short reply. 1.92. What is the ratio of the Imports(as % of merchandise exports) of Nigeria in 1999 to that in 2006?
Offer a terse response. 2.19. What is the ratio of the Imports(as % of merchandise exports) in St. Kitts and Nevis in 1999 to that in 2006?
Offer a very short reply. 1.19. What is the ratio of the Imports(as % of merchandise exports) in Vietnam in 1999 to that in 2006?
Offer a very short reply. 0.73. What is the ratio of the Imports(as % of merchandise exports) in India in 1999 to that in 2007?
Offer a terse response. 1.84. What is the ratio of the Imports(as % of merchandise exports) of Nigeria in 1999 to that in 2007?
Offer a terse response. 1.66. What is the ratio of the Imports(as % of merchandise exports) in St. Kitts and Nevis in 1999 to that in 2007?
Give a very brief answer. 1.19. What is the ratio of the Imports(as % of merchandise exports) in Vietnam in 1999 to that in 2007?
Keep it short and to the point. 0.93. What is the ratio of the Imports(as % of merchandise exports) in India in 1999 to that in 2008?
Give a very brief answer. 2.2. What is the ratio of the Imports(as % of merchandise exports) of Nigeria in 1999 to that in 2008?
Offer a terse response. 1.22. What is the ratio of the Imports(as % of merchandise exports) in St. Kitts and Nevis in 1999 to that in 2008?
Your response must be concise. 1.31. What is the ratio of the Imports(as % of merchandise exports) in Vietnam in 1999 to that in 2008?
Give a very brief answer. 0.92. What is the ratio of the Imports(as % of merchandise exports) in India in 2000 to that in 2001?
Your response must be concise. 0.87. What is the ratio of the Imports(as % of merchandise exports) in Nigeria in 2000 to that in 2001?
Provide a succinct answer. 0.35. What is the ratio of the Imports(as % of merchandise exports) of St. Kitts and Nevis in 2000 to that in 2001?
Offer a very short reply. 1.28. What is the ratio of the Imports(as % of merchandise exports) in Vietnam in 2000 to that in 2001?
Provide a succinct answer. 0.87. What is the ratio of the Imports(as % of merchandise exports) in India in 2000 to that in 2002?
Your answer should be compact. 1.05. What is the ratio of the Imports(as % of merchandise exports) in Nigeria in 2000 to that in 2002?
Provide a short and direct response. 0.9. What is the ratio of the Imports(as % of merchandise exports) of St. Kitts and Nevis in 2000 to that in 2002?
Give a very brief answer. 0.95. What is the ratio of the Imports(as % of merchandise exports) of Vietnam in 2000 to that in 2002?
Keep it short and to the point. 0.93. What is the ratio of the Imports(as % of merchandise exports) of India in 2000 to that in 2003?
Ensure brevity in your answer.  1.06. What is the ratio of the Imports(as % of merchandise exports) of Nigeria in 2000 to that in 2003?
Keep it short and to the point. 1.53. What is the ratio of the Imports(as % of merchandise exports) in St. Kitts and Nevis in 2000 to that in 2003?
Offer a very short reply. 1.07. What is the ratio of the Imports(as % of merchandise exports) in Vietnam in 2000 to that in 2003?
Give a very brief answer. 0.91. What is the ratio of the Imports(as % of merchandise exports) of India in 2000 to that in 2006?
Your response must be concise. 1.95. What is the ratio of the Imports(as % of merchandise exports) in Nigeria in 2000 to that in 2006?
Make the answer very short. 1.39. What is the ratio of the Imports(as % of merchandise exports) in St. Kitts and Nevis in 2000 to that in 2006?
Make the answer very short. 1.38. What is the ratio of the Imports(as % of merchandise exports) of Vietnam in 2000 to that in 2006?
Make the answer very short. 0.73. What is the ratio of the Imports(as % of merchandise exports) of India in 2000 to that in 2007?
Make the answer very short. 1.87. What is the ratio of the Imports(as % of merchandise exports) in Nigeria in 2000 to that in 2007?
Your answer should be very brief. 1.06. What is the ratio of the Imports(as % of merchandise exports) in St. Kitts and Nevis in 2000 to that in 2007?
Offer a terse response. 1.38. What is the ratio of the Imports(as % of merchandise exports) of Vietnam in 2000 to that in 2007?
Give a very brief answer. 0.92. What is the ratio of the Imports(as % of merchandise exports) of India in 2000 to that in 2008?
Keep it short and to the point. 2.23. What is the ratio of the Imports(as % of merchandise exports) of Nigeria in 2000 to that in 2008?
Keep it short and to the point. 0.78. What is the ratio of the Imports(as % of merchandise exports) in St. Kitts and Nevis in 2000 to that in 2008?
Provide a succinct answer. 1.52. What is the ratio of the Imports(as % of merchandise exports) in Vietnam in 2000 to that in 2008?
Provide a succinct answer. 0.92. What is the ratio of the Imports(as % of merchandise exports) of India in 2001 to that in 2002?
Provide a succinct answer. 1.21. What is the ratio of the Imports(as % of merchandise exports) of Nigeria in 2001 to that in 2002?
Provide a short and direct response. 2.55. What is the ratio of the Imports(as % of merchandise exports) of St. Kitts and Nevis in 2001 to that in 2002?
Keep it short and to the point. 0.74. What is the ratio of the Imports(as % of merchandise exports) in Vietnam in 2001 to that in 2002?
Offer a terse response. 1.08. What is the ratio of the Imports(as % of merchandise exports) of India in 2001 to that in 2003?
Your answer should be compact. 1.22. What is the ratio of the Imports(as % of merchandise exports) in Nigeria in 2001 to that in 2003?
Keep it short and to the point. 4.33. What is the ratio of the Imports(as % of merchandise exports) of St. Kitts and Nevis in 2001 to that in 2003?
Give a very brief answer. 0.84. What is the ratio of the Imports(as % of merchandise exports) of Vietnam in 2001 to that in 2003?
Your answer should be compact. 1.05. What is the ratio of the Imports(as % of merchandise exports) in India in 2001 to that in 2006?
Offer a terse response. 2.24. What is the ratio of the Imports(as % of merchandise exports) in Nigeria in 2001 to that in 2006?
Keep it short and to the point. 3.92. What is the ratio of the Imports(as % of merchandise exports) of St. Kitts and Nevis in 2001 to that in 2006?
Offer a terse response. 1.08. What is the ratio of the Imports(as % of merchandise exports) in Vietnam in 2001 to that in 2006?
Provide a short and direct response. 0.84. What is the ratio of the Imports(as % of merchandise exports) of India in 2001 to that in 2007?
Make the answer very short. 2.15. What is the ratio of the Imports(as % of merchandise exports) of Nigeria in 2001 to that in 2007?
Offer a very short reply. 2.99. What is the ratio of the Imports(as % of merchandise exports) of St. Kitts and Nevis in 2001 to that in 2007?
Ensure brevity in your answer.  1.08. What is the ratio of the Imports(as % of merchandise exports) of Vietnam in 2001 to that in 2007?
Make the answer very short. 1.06. What is the ratio of the Imports(as % of merchandise exports) in India in 2001 to that in 2008?
Make the answer very short. 2.57. What is the ratio of the Imports(as % of merchandise exports) in Nigeria in 2001 to that in 2008?
Offer a terse response. 2.2. What is the ratio of the Imports(as % of merchandise exports) in St. Kitts and Nevis in 2001 to that in 2008?
Offer a terse response. 1.19. What is the ratio of the Imports(as % of merchandise exports) of Vietnam in 2001 to that in 2008?
Provide a succinct answer. 1.06. What is the ratio of the Imports(as % of merchandise exports) in India in 2002 to that in 2003?
Ensure brevity in your answer.  1.01. What is the ratio of the Imports(as % of merchandise exports) of Nigeria in 2002 to that in 2003?
Give a very brief answer. 1.69. What is the ratio of the Imports(as % of merchandise exports) of St. Kitts and Nevis in 2002 to that in 2003?
Give a very brief answer. 1.13. What is the ratio of the Imports(as % of merchandise exports) in Vietnam in 2002 to that in 2003?
Give a very brief answer. 0.97. What is the ratio of the Imports(as % of merchandise exports) of India in 2002 to that in 2006?
Keep it short and to the point. 1.85. What is the ratio of the Imports(as % of merchandise exports) of Nigeria in 2002 to that in 2006?
Offer a very short reply. 1.54. What is the ratio of the Imports(as % of merchandise exports) in St. Kitts and Nevis in 2002 to that in 2006?
Keep it short and to the point. 1.45. What is the ratio of the Imports(as % of merchandise exports) in Vietnam in 2002 to that in 2006?
Offer a very short reply. 0.78. What is the ratio of the Imports(as % of merchandise exports) of India in 2002 to that in 2007?
Make the answer very short. 1.77. What is the ratio of the Imports(as % of merchandise exports) in Nigeria in 2002 to that in 2007?
Keep it short and to the point. 1.17. What is the ratio of the Imports(as % of merchandise exports) of St. Kitts and Nevis in 2002 to that in 2007?
Offer a terse response. 1.45. What is the ratio of the Imports(as % of merchandise exports) in India in 2002 to that in 2008?
Give a very brief answer. 2.12. What is the ratio of the Imports(as % of merchandise exports) in Nigeria in 2002 to that in 2008?
Offer a terse response. 0.86. What is the ratio of the Imports(as % of merchandise exports) of St. Kitts and Nevis in 2002 to that in 2008?
Offer a terse response. 1.6. What is the ratio of the Imports(as % of merchandise exports) of Vietnam in 2002 to that in 2008?
Your answer should be compact. 0.98. What is the ratio of the Imports(as % of merchandise exports) of India in 2003 to that in 2006?
Ensure brevity in your answer.  1.83. What is the ratio of the Imports(as % of merchandise exports) in Nigeria in 2003 to that in 2006?
Make the answer very short. 0.91. What is the ratio of the Imports(as % of merchandise exports) in St. Kitts and Nevis in 2003 to that in 2006?
Your answer should be very brief. 1.29. What is the ratio of the Imports(as % of merchandise exports) of Vietnam in 2003 to that in 2006?
Your answer should be compact. 0.8. What is the ratio of the Imports(as % of merchandise exports) of India in 2003 to that in 2007?
Provide a succinct answer. 1.76. What is the ratio of the Imports(as % of merchandise exports) of Nigeria in 2003 to that in 2007?
Provide a succinct answer. 0.69. What is the ratio of the Imports(as % of merchandise exports) of St. Kitts and Nevis in 2003 to that in 2007?
Offer a very short reply. 1.28. What is the ratio of the Imports(as % of merchandise exports) in Vietnam in 2003 to that in 2007?
Ensure brevity in your answer.  1.02. What is the ratio of the Imports(as % of merchandise exports) of India in 2003 to that in 2008?
Make the answer very short. 2.1. What is the ratio of the Imports(as % of merchandise exports) in Nigeria in 2003 to that in 2008?
Make the answer very short. 0.51. What is the ratio of the Imports(as % of merchandise exports) of St. Kitts and Nevis in 2003 to that in 2008?
Keep it short and to the point. 1.42. What is the ratio of the Imports(as % of merchandise exports) in Vietnam in 2003 to that in 2008?
Ensure brevity in your answer.  1.01. What is the ratio of the Imports(as % of merchandise exports) of India in 2006 to that in 2007?
Make the answer very short. 0.96. What is the ratio of the Imports(as % of merchandise exports) of Nigeria in 2006 to that in 2007?
Provide a succinct answer. 0.76. What is the ratio of the Imports(as % of merchandise exports) of Vietnam in 2006 to that in 2007?
Offer a terse response. 1.26. What is the ratio of the Imports(as % of merchandise exports) of India in 2006 to that in 2008?
Provide a succinct answer. 1.15. What is the ratio of the Imports(as % of merchandise exports) of Nigeria in 2006 to that in 2008?
Make the answer very short. 0.56. What is the ratio of the Imports(as % of merchandise exports) in St. Kitts and Nevis in 2006 to that in 2008?
Your answer should be very brief. 1.1. What is the ratio of the Imports(as % of merchandise exports) of Vietnam in 2006 to that in 2008?
Keep it short and to the point. 1.26. What is the ratio of the Imports(as % of merchandise exports) of India in 2007 to that in 2008?
Your answer should be very brief. 1.2. What is the ratio of the Imports(as % of merchandise exports) of Nigeria in 2007 to that in 2008?
Your response must be concise. 0.74. What is the ratio of the Imports(as % of merchandise exports) in St. Kitts and Nevis in 2007 to that in 2008?
Provide a succinct answer. 1.11. What is the difference between the highest and the second highest Imports(as % of merchandise exports) of India?
Your response must be concise. 0.53. What is the difference between the highest and the second highest Imports(as % of merchandise exports) in Nigeria?
Keep it short and to the point. 1.16. What is the difference between the highest and the second highest Imports(as % of merchandise exports) of St. Kitts and Nevis?
Your answer should be very brief. 0.13. What is the difference between the highest and the second highest Imports(as % of merchandise exports) of Vietnam?
Keep it short and to the point. 0.63. What is the difference between the highest and the lowest Imports(as % of merchandise exports) in India?
Make the answer very short. 2.46. What is the difference between the highest and the lowest Imports(as % of merchandise exports) of Nigeria?
Keep it short and to the point. 2.01. What is the difference between the highest and the lowest Imports(as % of merchandise exports) of Vietnam?
Keep it short and to the point. 1.08. 